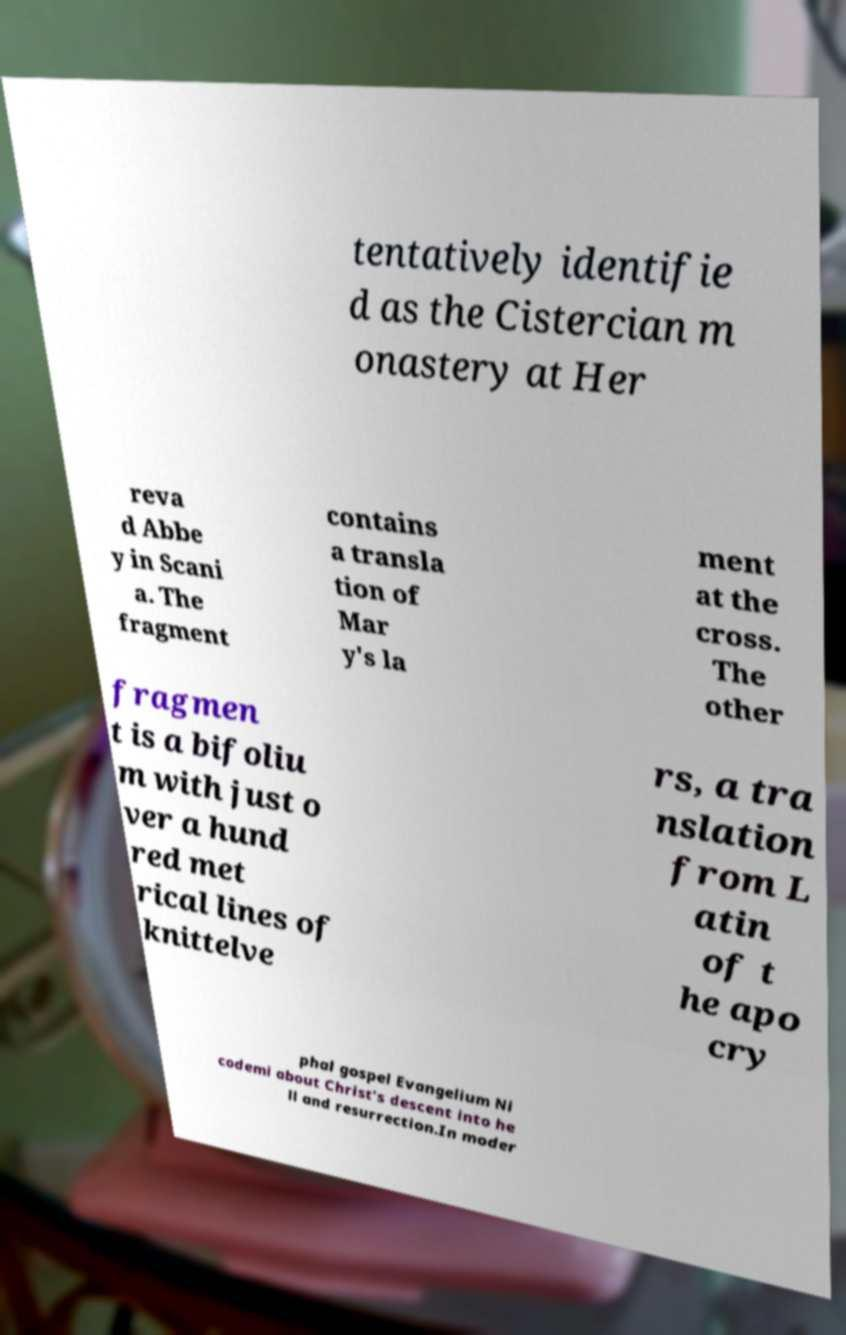Could you extract and type out the text from this image? tentatively identifie d as the Cistercian m onastery at Her reva d Abbe y in Scani a. The fragment contains a transla tion of Mar y's la ment at the cross. The other fragmen t is a bifoliu m with just o ver a hund red met rical lines of knittelve rs, a tra nslation from L atin of t he apo cry phal gospel Evangelium Ni codemi about Christ's descent into he ll and resurrection.In moder 